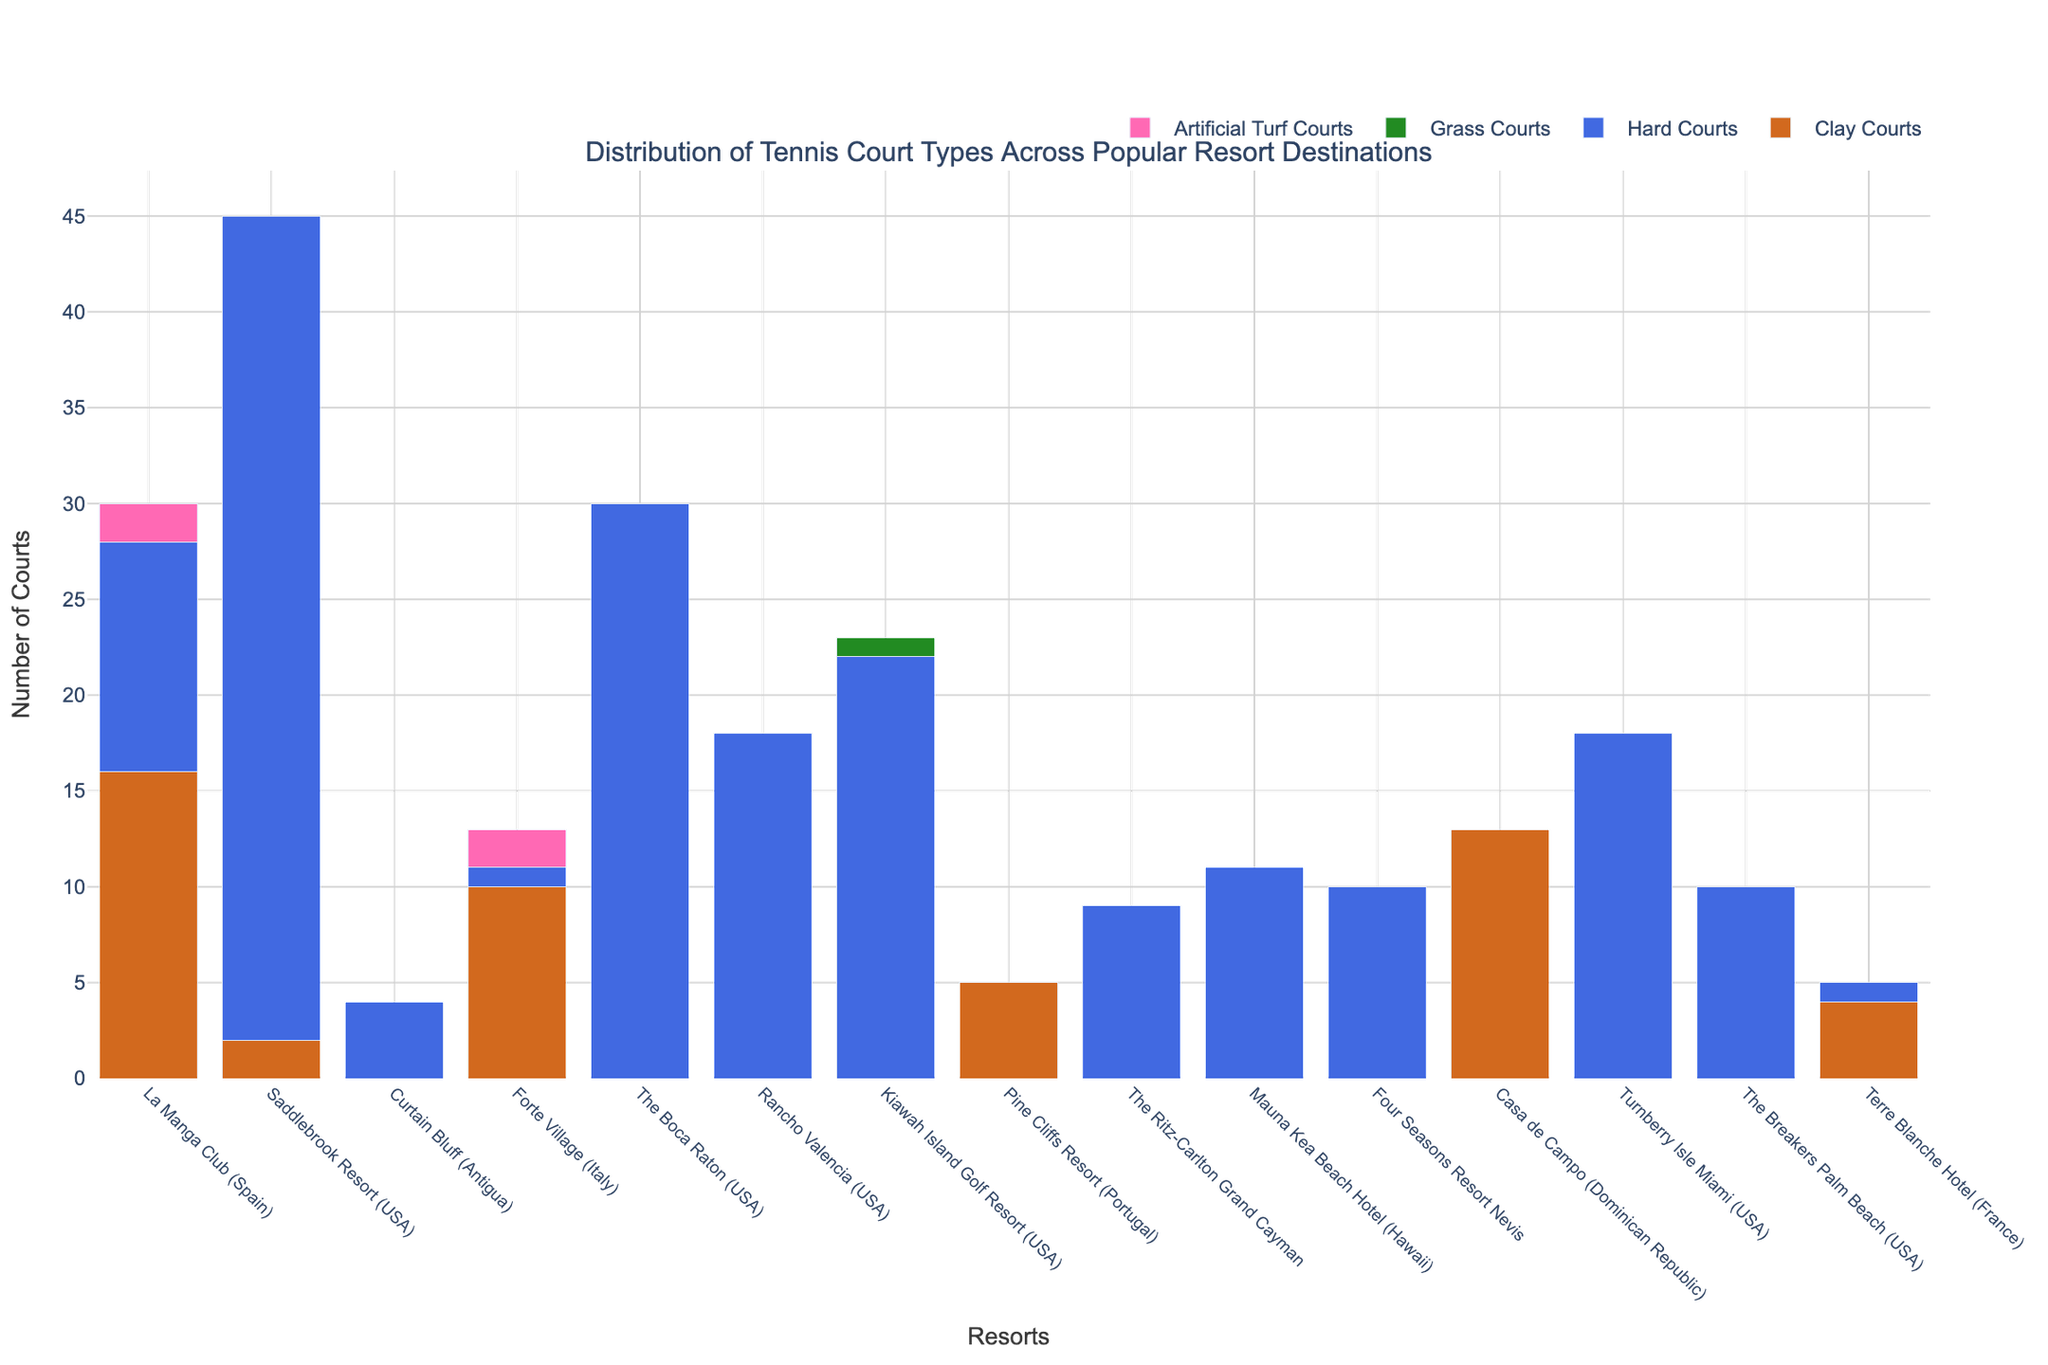Which resort has the highest number of hard courts? Look at the heights of the blue bars (representing hard courts) for each resort. The highest bar is for Saddlebrook Resort.
Answer: Saddlebrook Resort How many total clay courts are available across La Manga Club and Casa de Campo? Add the number of clay courts from La Manga Club and Casa de Campo. La Manga Club has 16 clay courts, and Casa de Campo has 13 clay courts. The total is 16 + 13 = 29.
Answer: 29 Which resorts have no hard courts at all? Identify the resorts where the height of the blue bars (representing hard courts) is zero. These resorts are La Manga Club, Curtain Bluff, Pine Cliffs Resort, Casa de Campo, The Ritz-Carlton Grand Cayman, Four Seasons Resort Nevis, and The Breakers Palm Beach.
Answer: La Manga Club, Curtain Bluff, Pine Cliffs Resort, Casa de Campo, The Ritz-Carlton Grand Cayman, Four Seasons Resort Nevis, The Breakers Palm Beach Compare the number of artificial turf courts at Forte Village and La Manga Club. Which one has more? Look at the heights of the pink bars (representing artificial turf courts) for Forte Village and La Manga Club. Forte Village has 2, and La Manga Club also has 2. They are equal.
Answer: Equal What's the total number of grass courts among all the resorts? Sum up the number of grass courts from each resort. Only Kiawah Island Golf Resort has 1 grass court. So, the total is 1.
Answer: 1 Which court type is most prevalent at The Boca Raton? Identify the tallest bar for The Boca Raton. The blue bar (representing hard courts) is the tallest, indicating it is most prevalent.
Answer: Hard Courts What's the difference between the total number of courts at Saddlebrook Resort and the total number of courts at Rancho Valencia? Sum up the total number of courts for each type at Saddlebrook Resort and Rancho Valencia. Saddlebrook Resort has 2 clay courts and 43 hard courts, making a total of 45. Rancho Valencia has 18 hard courts only. The difference is 45 - 18 = 27.
Answer: 27 What's the average number of hard courts at the resorts located in the USA? Sum the number of hard courts for all resorts in the USA and divide by the number of these resorts. There are 5 resorts (Saddlebrook Resort, The Boca Raton, Rancho Valencia, Kiawah Island Golf Resort, Turnberry Isle Miami) with hard courts: 43 + 30 + 18 + 22 + 18 = 131. Average = 131 / 5 = 26.2.
Answer: 26.2 Among resorts with no clay courts, which one has the highest total number of courts? Find resorts with zero clay courts and sum their other types of courts. The one with the highest sum is the desired resort. The Boca Raton has the highest total number of courts (30 hard courts) among those with zero clay courts.
Answer: The Boca Raton 